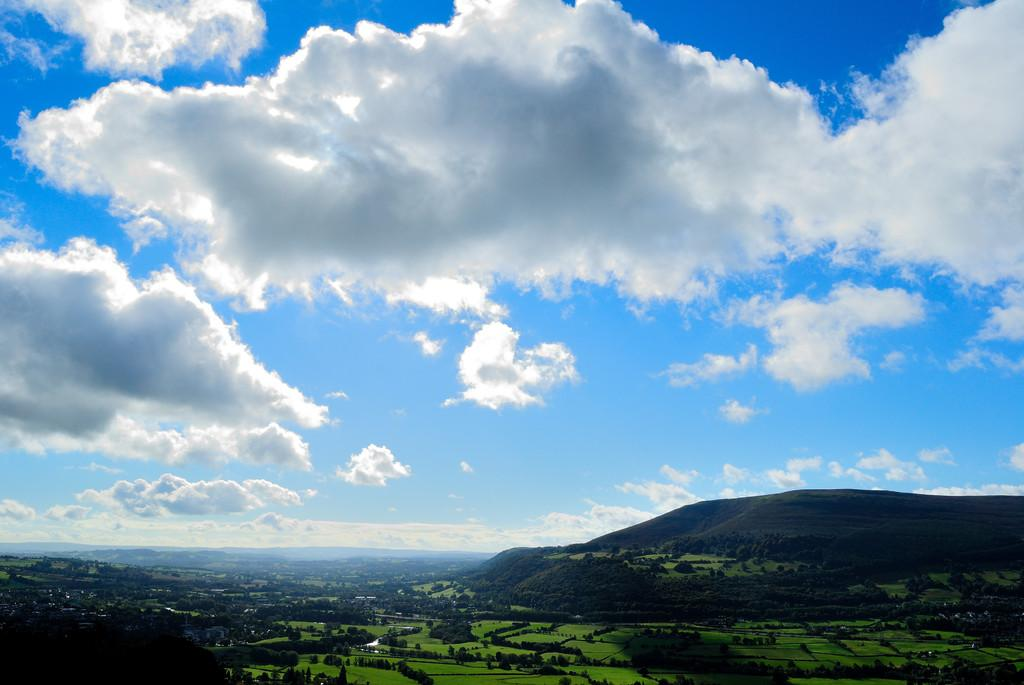What type of setting is depicted in the image? The image is an outside view. What natural elements can be seen in the image? There are many trees and hills in the image. What is visible in the sky in the image? The sky is visible in the image, and clouds are present. How many dimes can be seen on the ground in the image? There are no dimes present in the image; it features an outside view with trees, hills, and clouds in the sky. What type of tooth is visible in the image? There are no teeth or any dental-related objects present in the image. 